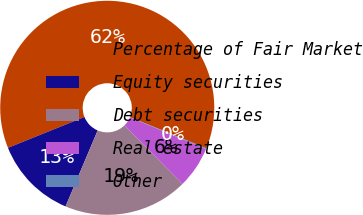Convert chart to OTSL. <chart><loc_0><loc_0><loc_500><loc_500><pie_chart><fcel>Percentage of Fair Market<fcel>Equity securities<fcel>Debt securities<fcel>Real estate<fcel>Other<nl><fcel>62.28%<fcel>12.54%<fcel>18.76%<fcel>6.32%<fcel>0.11%<nl></chart> 